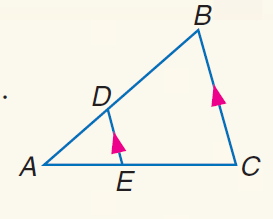Question: If A D = 8, A E = 12, and E C = 18, find A B.
Choices:
A. 15
B. 16
C. 18
D. 20
Answer with the letter. Answer: D 